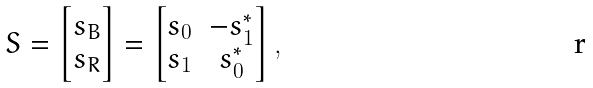<formula> <loc_0><loc_0><loc_500><loc_500>S = \begin{bmatrix} s _ { B } \\ s _ { R } \end{bmatrix} = \begin{bmatrix} s _ { 0 } & - s _ { 1 } ^ { * } \\ s _ { 1 } & s _ { 0 } ^ { * } \end{bmatrix} ,</formula> 